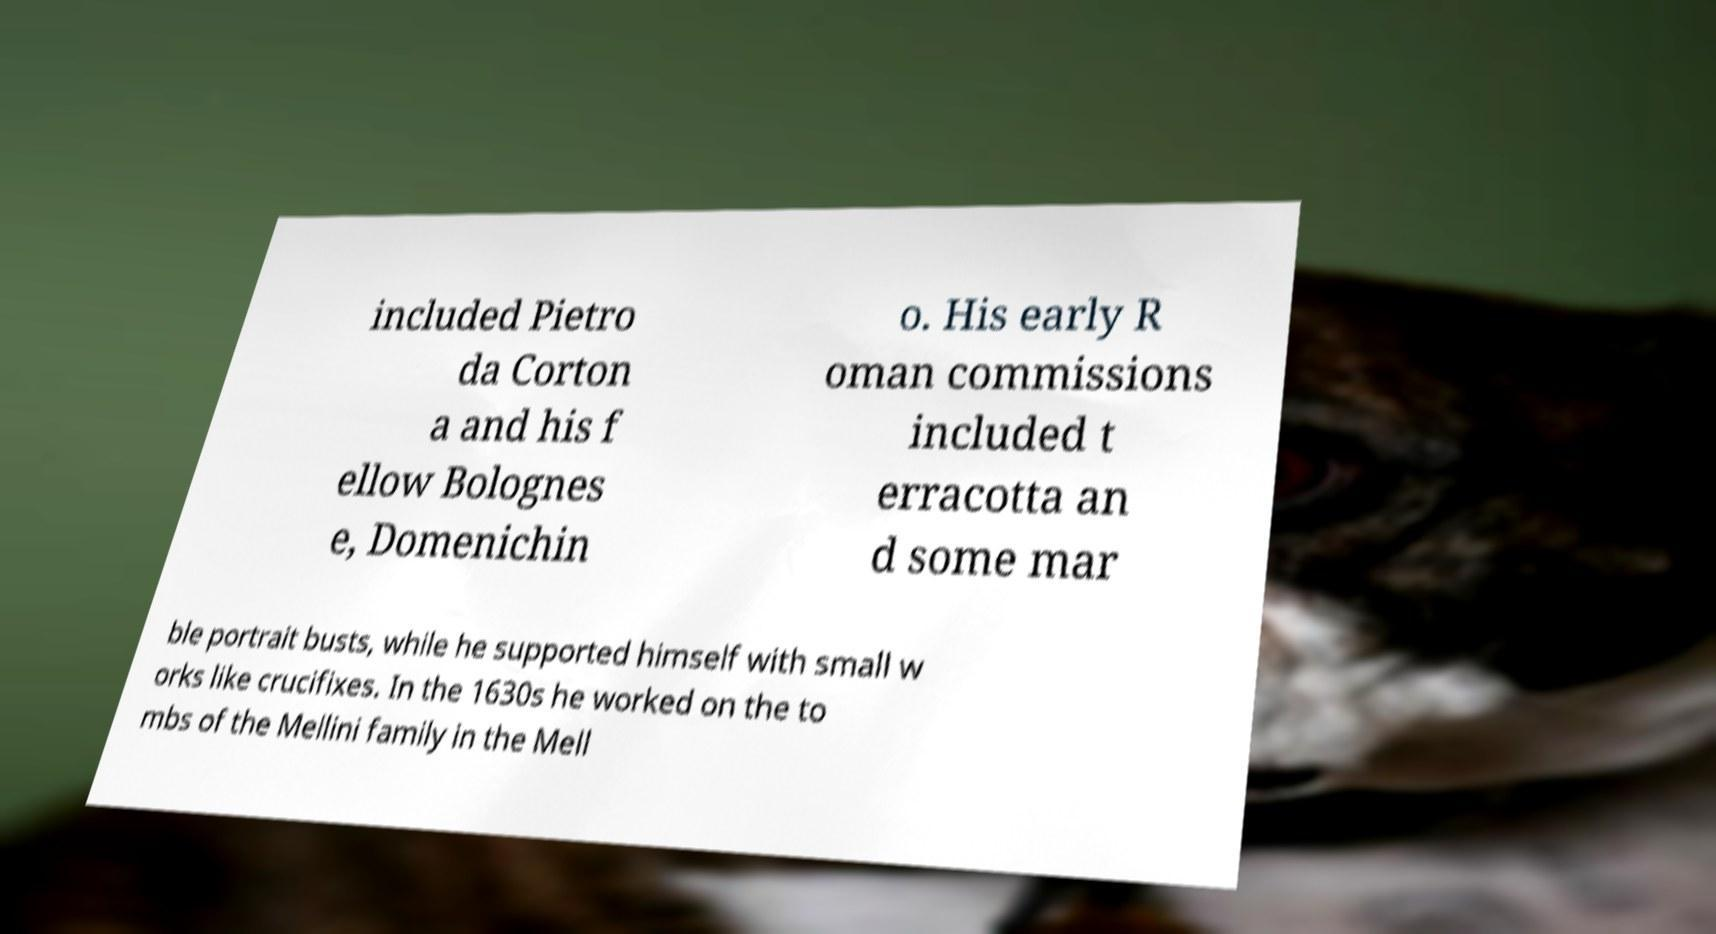For documentation purposes, I need the text within this image transcribed. Could you provide that? included Pietro da Corton a and his f ellow Bolognes e, Domenichin o. His early R oman commissions included t erracotta an d some mar ble portrait busts, while he supported himself with small w orks like crucifixes. In the 1630s he worked on the to mbs of the Mellini family in the Mell 